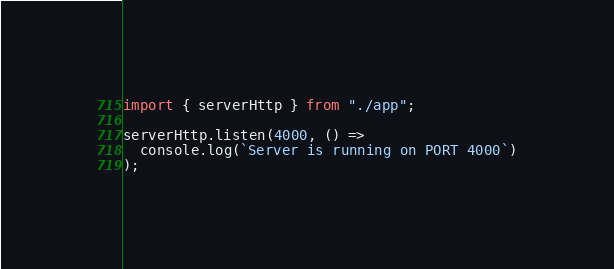Convert code to text. <code><loc_0><loc_0><loc_500><loc_500><_TypeScript_>import { serverHttp } from "./app";

serverHttp.listen(4000, () =>
  console.log(`Server is running on PORT 4000`)
);
</code> 